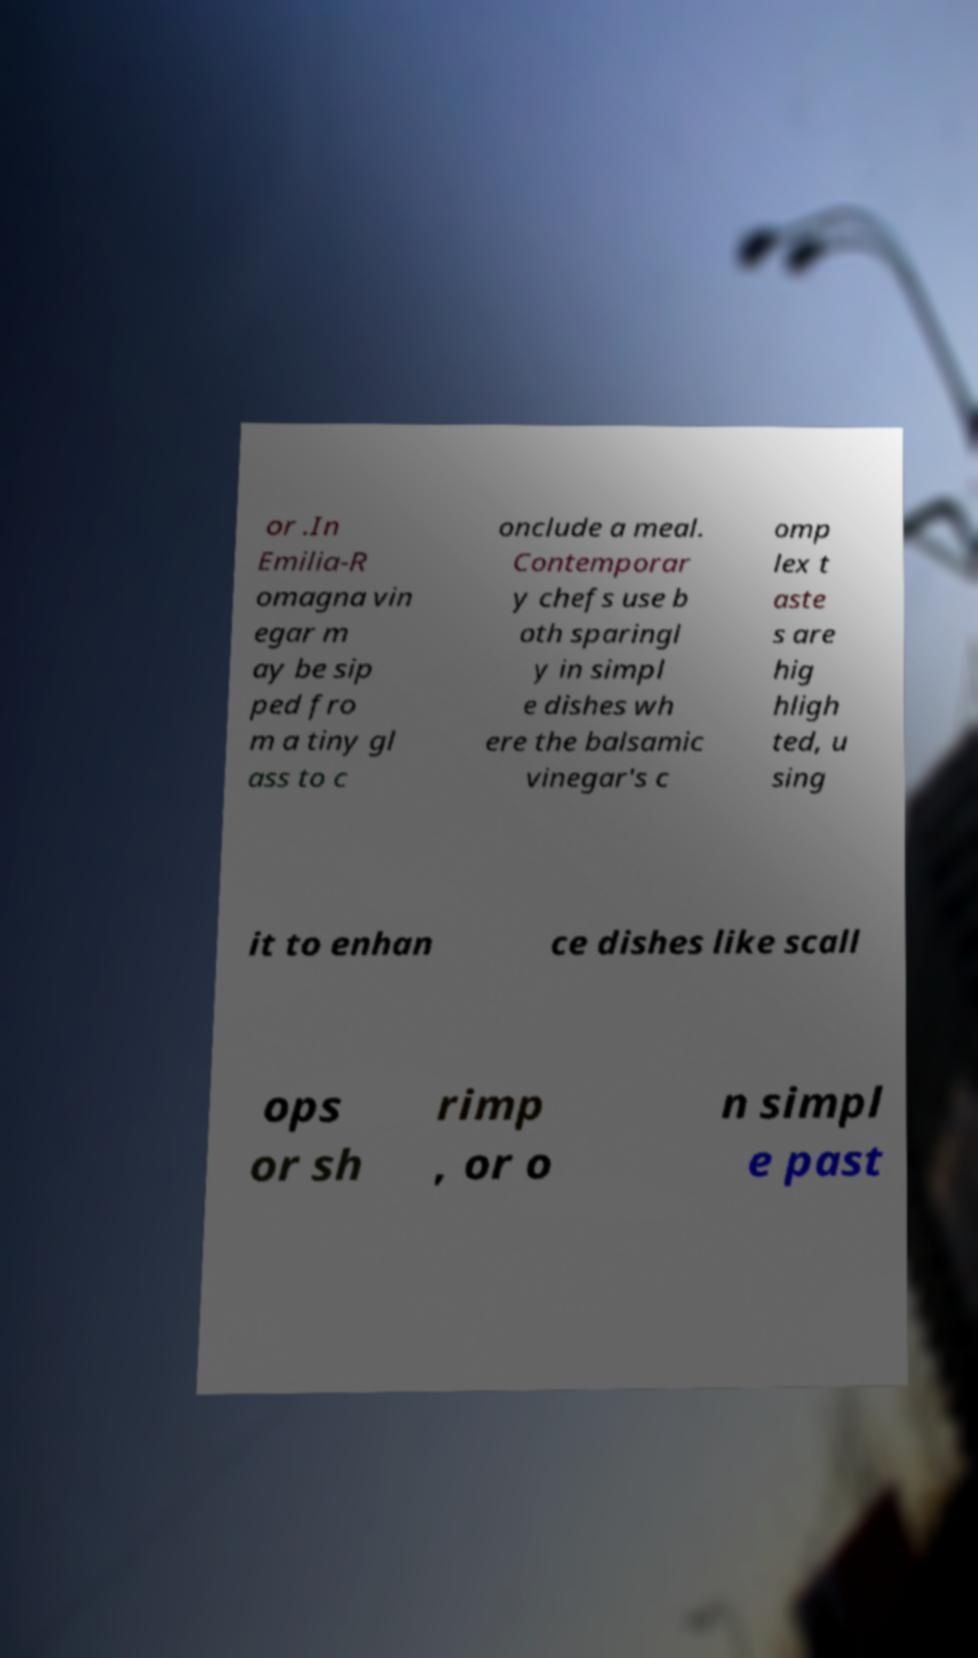I need the written content from this picture converted into text. Can you do that? or .In Emilia-R omagna vin egar m ay be sip ped fro m a tiny gl ass to c onclude a meal. Contemporar y chefs use b oth sparingl y in simpl e dishes wh ere the balsamic vinegar's c omp lex t aste s are hig hligh ted, u sing it to enhan ce dishes like scall ops or sh rimp , or o n simpl e past 